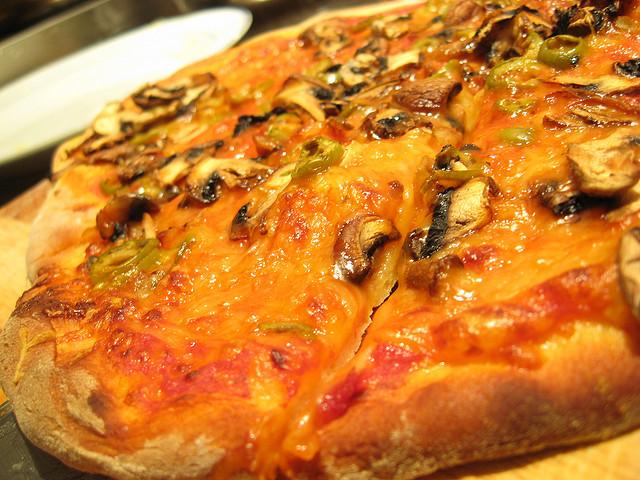Why are there some dark spots?
Give a very brief answer. Mushrooms. Is this healthy?
Be succinct. No. What is the yellow food?
Answer briefly. Cheese. Is the pizza burnt?
Answer briefly. No. Are there mushrooms on this pizza?
Write a very short answer. Yes. Is there enough for 4?
Write a very short answer. Yes. What style pizza is in the photo?
Concise answer only. Mushroom. What topping is most prominent on the pizza shown?
Write a very short answer. Mushrooms. Is the food on a plate?
Be succinct. No. What is on the pizza?
Give a very brief answer. Cheese and mushrooms. Has this food been cut?
Quick response, please. Yes. What kind of pizza is this?
Quick response, please. Mushroom. What vegetables are on the pizza?
Give a very brief answer. Mushrooms. What is the black topping on the pizza?
Concise answer only. Mushrooms. What kind of cheese is on the pizza?
Be succinct. Cheddar. 